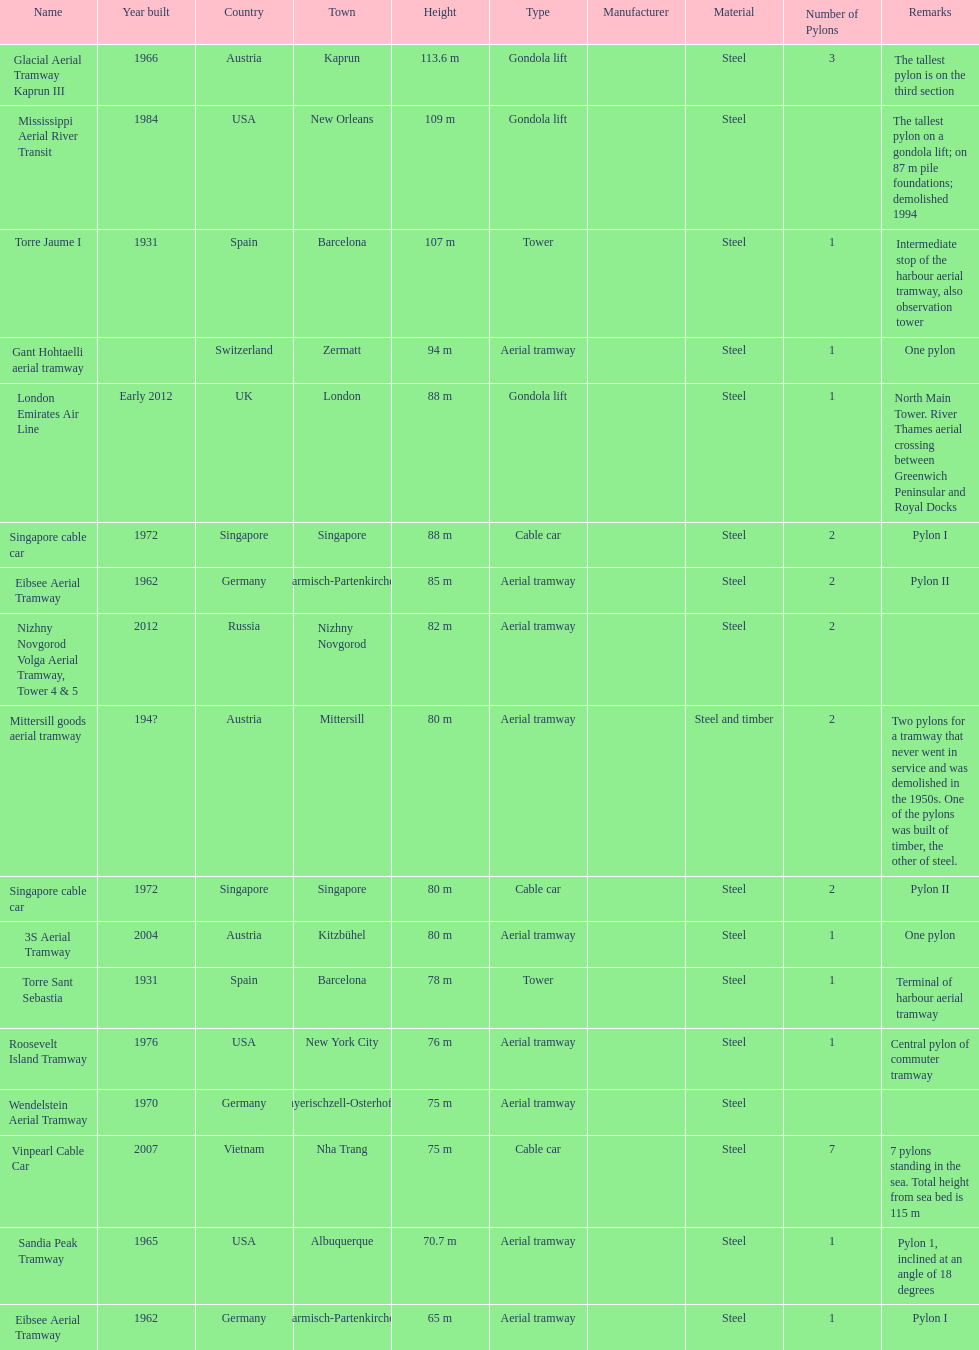What is the vertical distance in metres of the mississippi aerial river transit from base to summit? 109 m. 